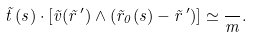Convert formula to latex. <formula><loc_0><loc_0><loc_500><loc_500>\vec { t } \, ( s ) \cdot \left [ \vec { v } ( \vec { r } \, ^ { \prime } ) \land ( \vec { r } _ { 0 } ( s ) - \vec { r } \, ^ { \prime } ) \right ] \simeq \frac { } { m } .</formula> 